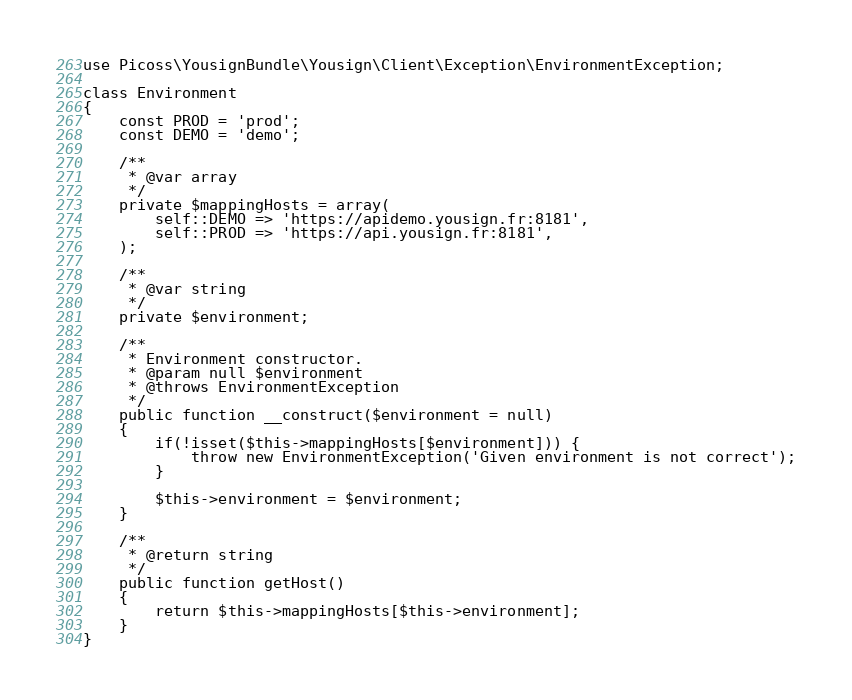<code> <loc_0><loc_0><loc_500><loc_500><_PHP_>
use Picoss\YousignBundle\Yousign\Client\Exception\EnvironmentException;

class Environment
{
    const PROD = 'prod';
    const DEMO = 'demo';

    /**
     * @var array
     */
    private $mappingHosts = array(
        self::DEMO => 'https://apidemo.yousign.fr:8181',
        self::PROD => 'https://api.yousign.fr:8181',
    );

    /**
     * @var string
     */
    private $environment;

    /**
     * Environment constructor.
     * @param null $environment
     * @throws EnvironmentException
     */
    public function __construct($environment = null)
    {
        if(!isset($this->mappingHosts[$environment])) {
            throw new EnvironmentException('Given environment is not correct');
        }

        $this->environment = $environment;
    }

    /**
     * @return string
     */
    public function getHost()
    {
        return $this->mappingHosts[$this->environment];
    }
}</code> 